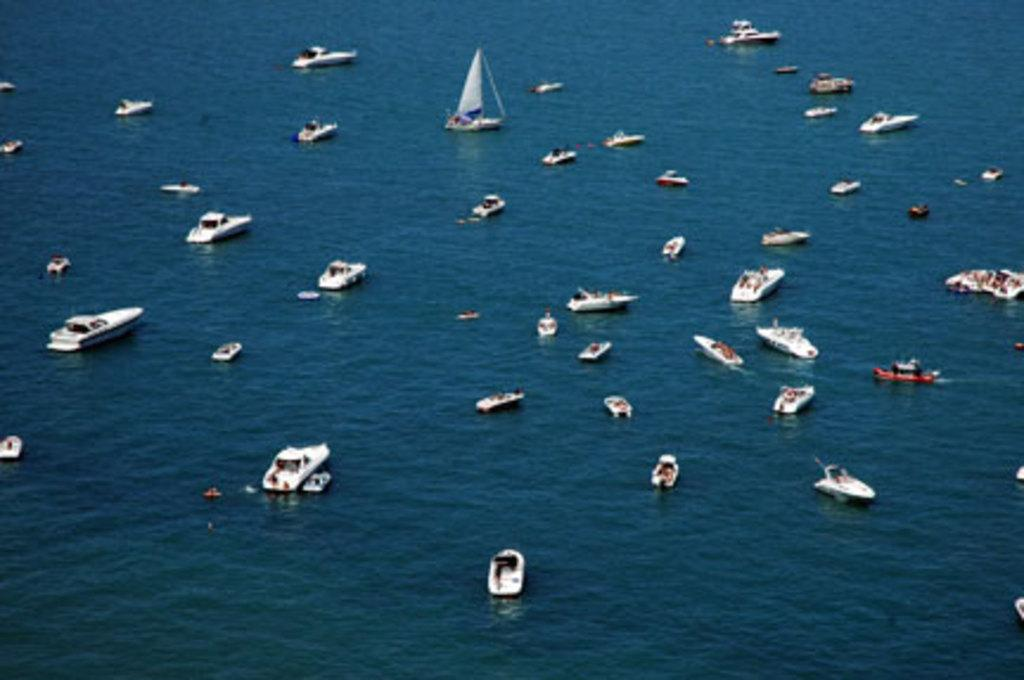What type of vehicles are in the image? There are boats in the image. Where are the boats located? The boats are on the water. What type of insurance is required for the boats in the image? There is no information about insurance in the image, as it only shows boats on the water. 